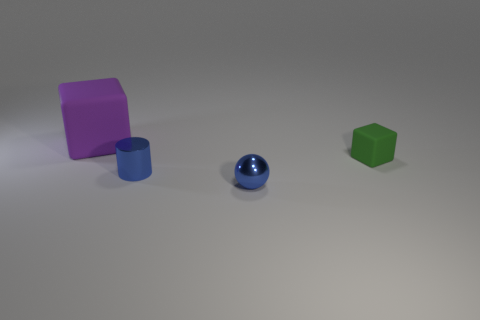Can you describe the different objects and their colors in the image? Certainly! There is a large purple cube, a small green cube, a large blue cylinder, and a small blue sphere. Each object has a matte surface and a distinct color, making them easily distinguishable from one another. 